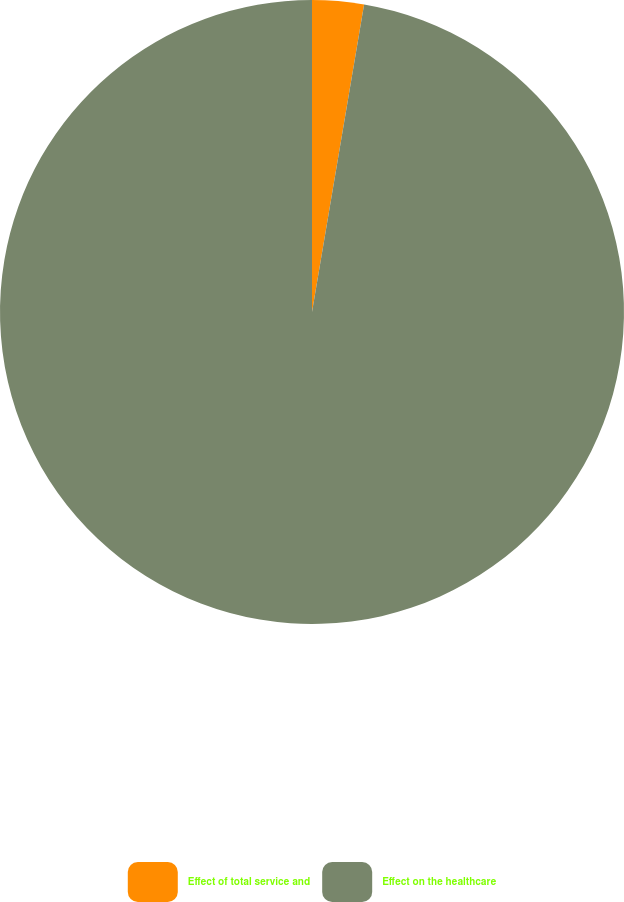Convert chart. <chart><loc_0><loc_0><loc_500><loc_500><pie_chart><fcel>Effect of total service and<fcel>Effect on the healthcare<nl><fcel>2.67%<fcel>97.33%<nl></chart> 